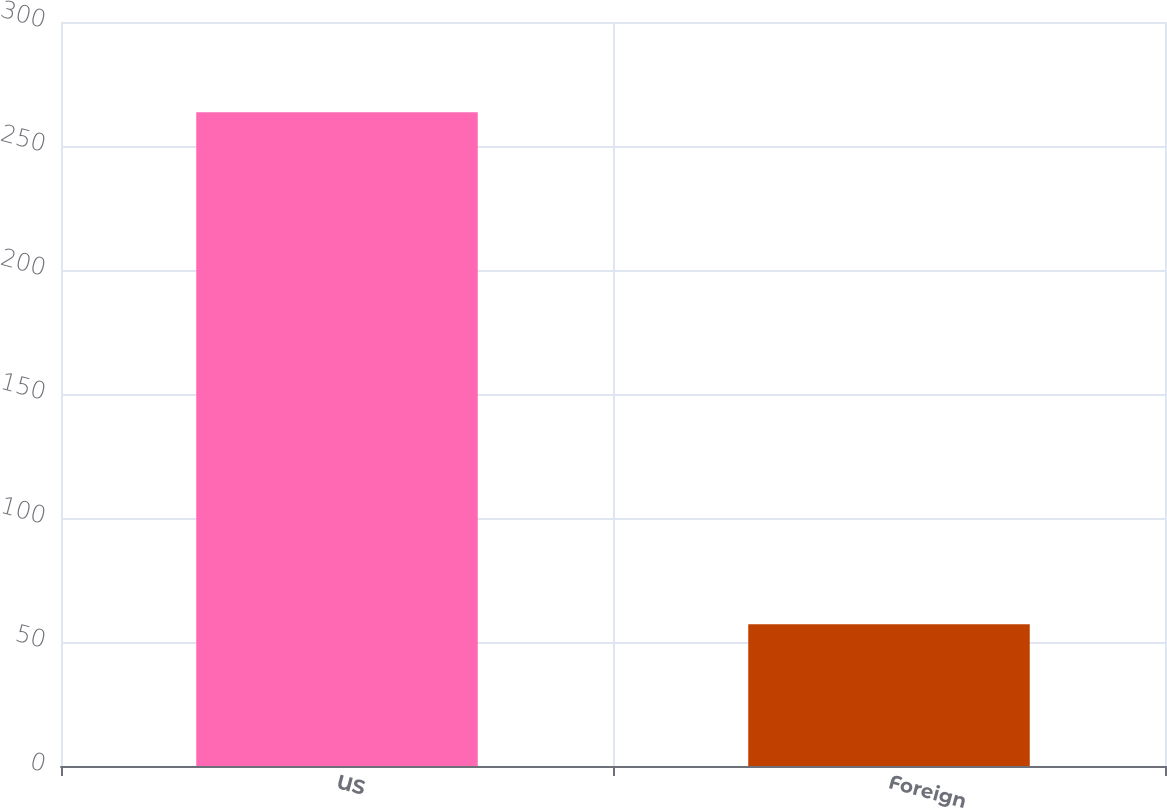Convert chart. <chart><loc_0><loc_0><loc_500><loc_500><bar_chart><fcel>US<fcel>Foreign<nl><fcel>263.6<fcel>57.2<nl></chart> 